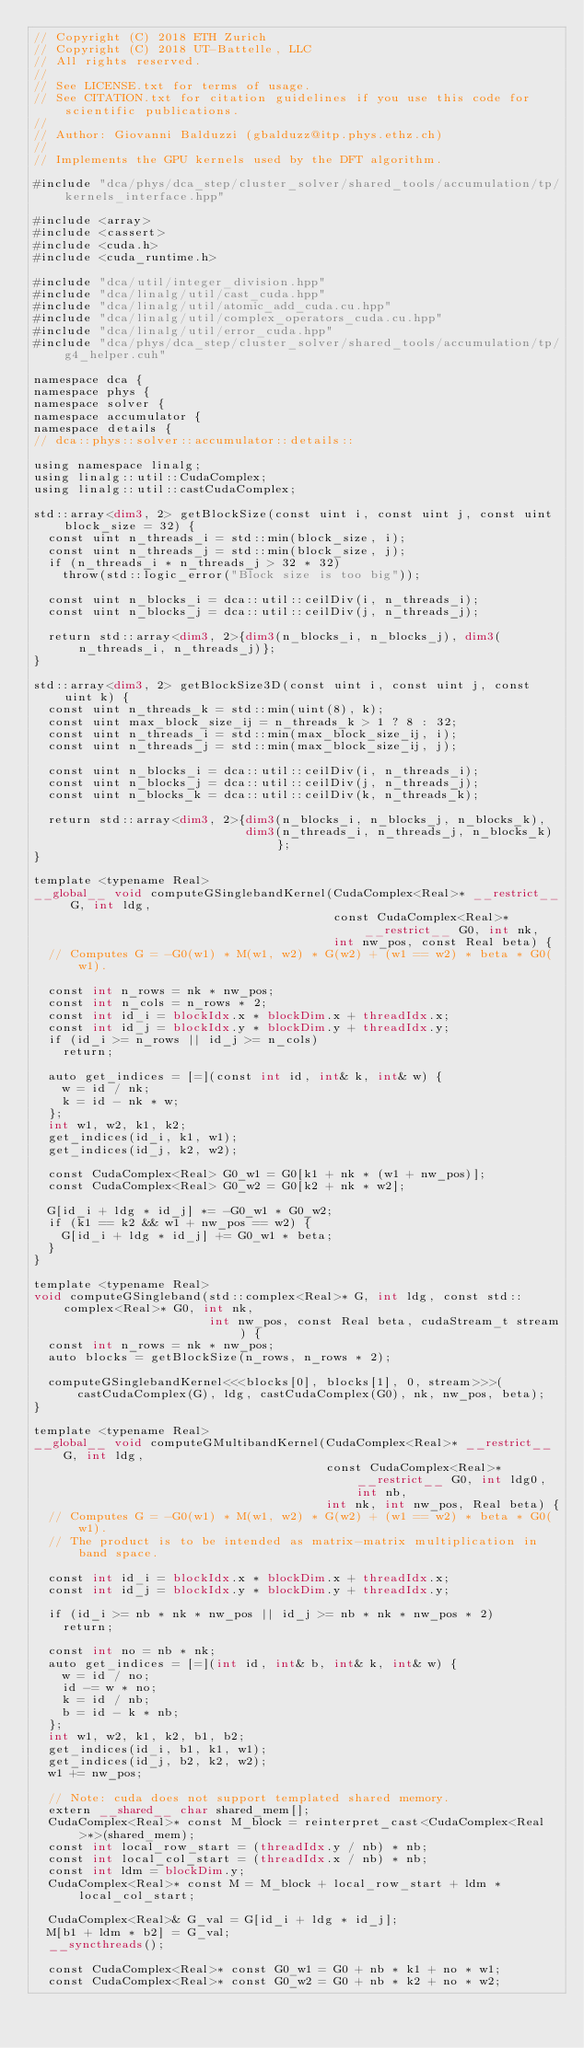<code> <loc_0><loc_0><loc_500><loc_500><_Cuda_>// Copyright (C) 2018 ETH Zurich
// Copyright (C) 2018 UT-Battelle, LLC
// All rights reserved.
//
// See LICENSE.txt for terms of usage.
// See CITATION.txt for citation guidelines if you use this code for scientific publications.
//
// Author: Giovanni Balduzzi (gbalduzz@itp.phys.ethz.ch)
//
// Implements the GPU kernels used by the DFT algorithm.

#include "dca/phys/dca_step/cluster_solver/shared_tools/accumulation/tp/kernels_interface.hpp"

#include <array>
#include <cassert>
#include <cuda.h>
#include <cuda_runtime.h>

#include "dca/util/integer_division.hpp"
#include "dca/linalg/util/cast_cuda.hpp"
#include "dca/linalg/util/atomic_add_cuda.cu.hpp"
#include "dca/linalg/util/complex_operators_cuda.cu.hpp"
#include "dca/linalg/util/error_cuda.hpp"
#include "dca/phys/dca_step/cluster_solver/shared_tools/accumulation/tp/g4_helper.cuh"

namespace dca {
namespace phys {
namespace solver {
namespace accumulator {
namespace details {
// dca::phys::solver::accumulator::details::

using namespace linalg;
using linalg::util::CudaComplex;
using linalg::util::castCudaComplex;

std::array<dim3, 2> getBlockSize(const uint i, const uint j, const uint block_size = 32) {
  const uint n_threads_i = std::min(block_size, i);
  const uint n_threads_j = std::min(block_size, j);
  if (n_threads_i * n_threads_j > 32 * 32)
    throw(std::logic_error("Block size is too big"));

  const uint n_blocks_i = dca::util::ceilDiv(i, n_threads_i);
  const uint n_blocks_j = dca::util::ceilDiv(j, n_threads_j);

  return std::array<dim3, 2>{dim3(n_blocks_i, n_blocks_j), dim3(n_threads_i, n_threads_j)};
}

std::array<dim3, 2> getBlockSize3D(const uint i, const uint j, const uint k) {
  const uint n_threads_k = std::min(uint(8), k);
  const uint max_block_size_ij = n_threads_k > 1 ? 8 : 32;
  const uint n_threads_i = std::min(max_block_size_ij, i);
  const uint n_threads_j = std::min(max_block_size_ij, j);

  const uint n_blocks_i = dca::util::ceilDiv(i, n_threads_i);
  const uint n_blocks_j = dca::util::ceilDiv(j, n_threads_j);
  const uint n_blocks_k = dca::util::ceilDiv(k, n_threads_k);

  return std::array<dim3, 2>{dim3(n_blocks_i, n_blocks_j, n_blocks_k),
                             dim3(n_threads_i, n_threads_j, n_blocks_k)};
}

template <typename Real>
__global__ void computeGSinglebandKernel(CudaComplex<Real>* __restrict__ G, int ldg,
                                         const CudaComplex<Real>* __restrict__ G0, int nk,
                                         int nw_pos, const Real beta) {
  // Computes G = -G0(w1) * M(w1, w2) * G(w2) + (w1 == w2) * beta * G0(w1).

  const int n_rows = nk * nw_pos;
  const int n_cols = n_rows * 2;
  const int id_i = blockIdx.x * blockDim.x + threadIdx.x;
  const int id_j = blockIdx.y * blockDim.y + threadIdx.y;
  if (id_i >= n_rows || id_j >= n_cols)
    return;

  auto get_indices = [=](const int id, int& k, int& w) {
    w = id / nk;
    k = id - nk * w;
  };
  int w1, w2, k1, k2;
  get_indices(id_i, k1, w1);
  get_indices(id_j, k2, w2);

  const CudaComplex<Real> G0_w1 = G0[k1 + nk * (w1 + nw_pos)];
  const CudaComplex<Real> G0_w2 = G0[k2 + nk * w2];

  G[id_i + ldg * id_j] *= -G0_w1 * G0_w2;
  if (k1 == k2 && w1 + nw_pos == w2) {
    G[id_i + ldg * id_j] += G0_w1 * beta;
  }
}

template <typename Real>
void computeGSingleband(std::complex<Real>* G, int ldg, const std::complex<Real>* G0, int nk,
                        int nw_pos, const Real beta, cudaStream_t stream) {
  const int n_rows = nk * nw_pos;
  auto blocks = getBlockSize(n_rows, n_rows * 2);

  computeGSinglebandKernel<<<blocks[0], blocks[1], 0, stream>>>(
      castCudaComplex(G), ldg, castCudaComplex(G0), nk, nw_pos, beta);
}

template <typename Real>
__global__ void computeGMultibandKernel(CudaComplex<Real>* __restrict__ G, int ldg,
                                        const CudaComplex<Real>* __restrict__ G0, int ldg0, int nb,
                                        int nk, int nw_pos, Real beta) {
  // Computes G = -G0(w1) * M(w1, w2) * G(w2) + (w1 == w2) * beta * G0(w1).
  // The product is to be intended as matrix-matrix multiplication in band space.

  const int id_i = blockIdx.x * blockDim.x + threadIdx.x;
  const int id_j = blockIdx.y * blockDim.y + threadIdx.y;

  if (id_i >= nb * nk * nw_pos || id_j >= nb * nk * nw_pos * 2)
    return;

  const int no = nb * nk;
  auto get_indices = [=](int id, int& b, int& k, int& w) {
    w = id / no;
    id -= w * no;
    k = id / nb;
    b = id - k * nb;
  };
  int w1, w2, k1, k2, b1, b2;
  get_indices(id_i, b1, k1, w1);
  get_indices(id_j, b2, k2, w2);
  w1 += nw_pos;

  // Note: cuda does not support templated shared memory.
  extern __shared__ char shared_mem[];
  CudaComplex<Real>* const M_block = reinterpret_cast<CudaComplex<Real>*>(shared_mem);
  const int local_row_start = (threadIdx.y / nb) * nb;
  const int local_col_start = (threadIdx.x / nb) * nb;
  const int ldm = blockDim.y;
  CudaComplex<Real>* const M = M_block + local_row_start + ldm * local_col_start;

  CudaComplex<Real>& G_val = G[id_i + ldg * id_j];
  M[b1 + ldm * b2] = G_val;
  __syncthreads();

  const CudaComplex<Real>* const G0_w1 = G0 + nb * k1 + no * w1;
  const CudaComplex<Real>* const G0_w2 = G0 + nb * k2 + no * w2;
</code> 